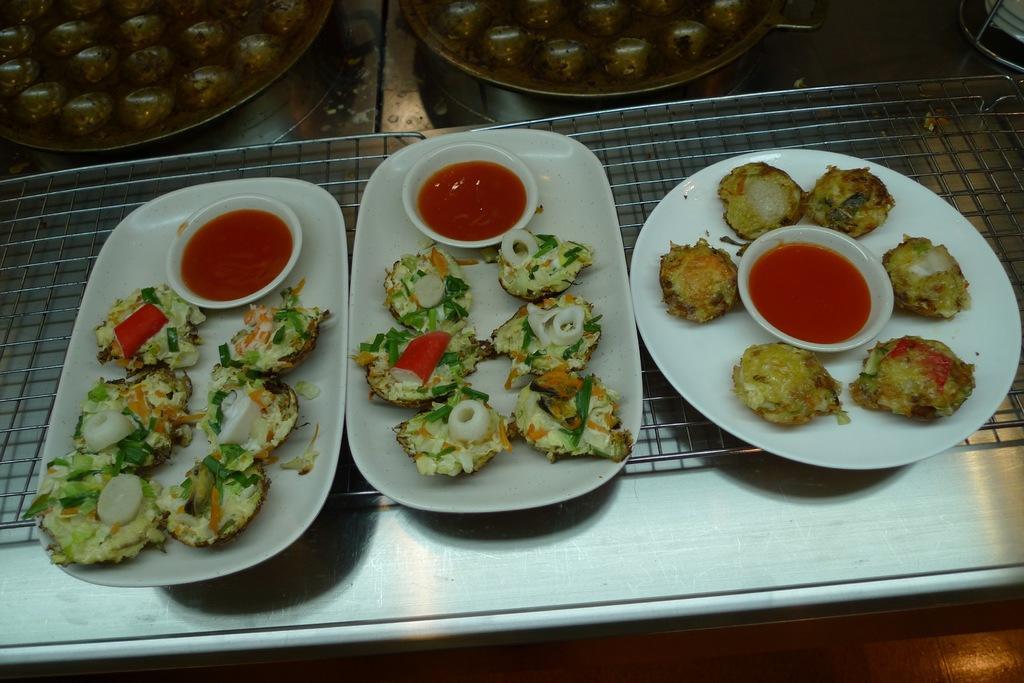Describe this image in one or two sentences. In this image there are three plates of food items with three sauce cups present. These plates are placed on the grill. In the background there are two plates visible. 